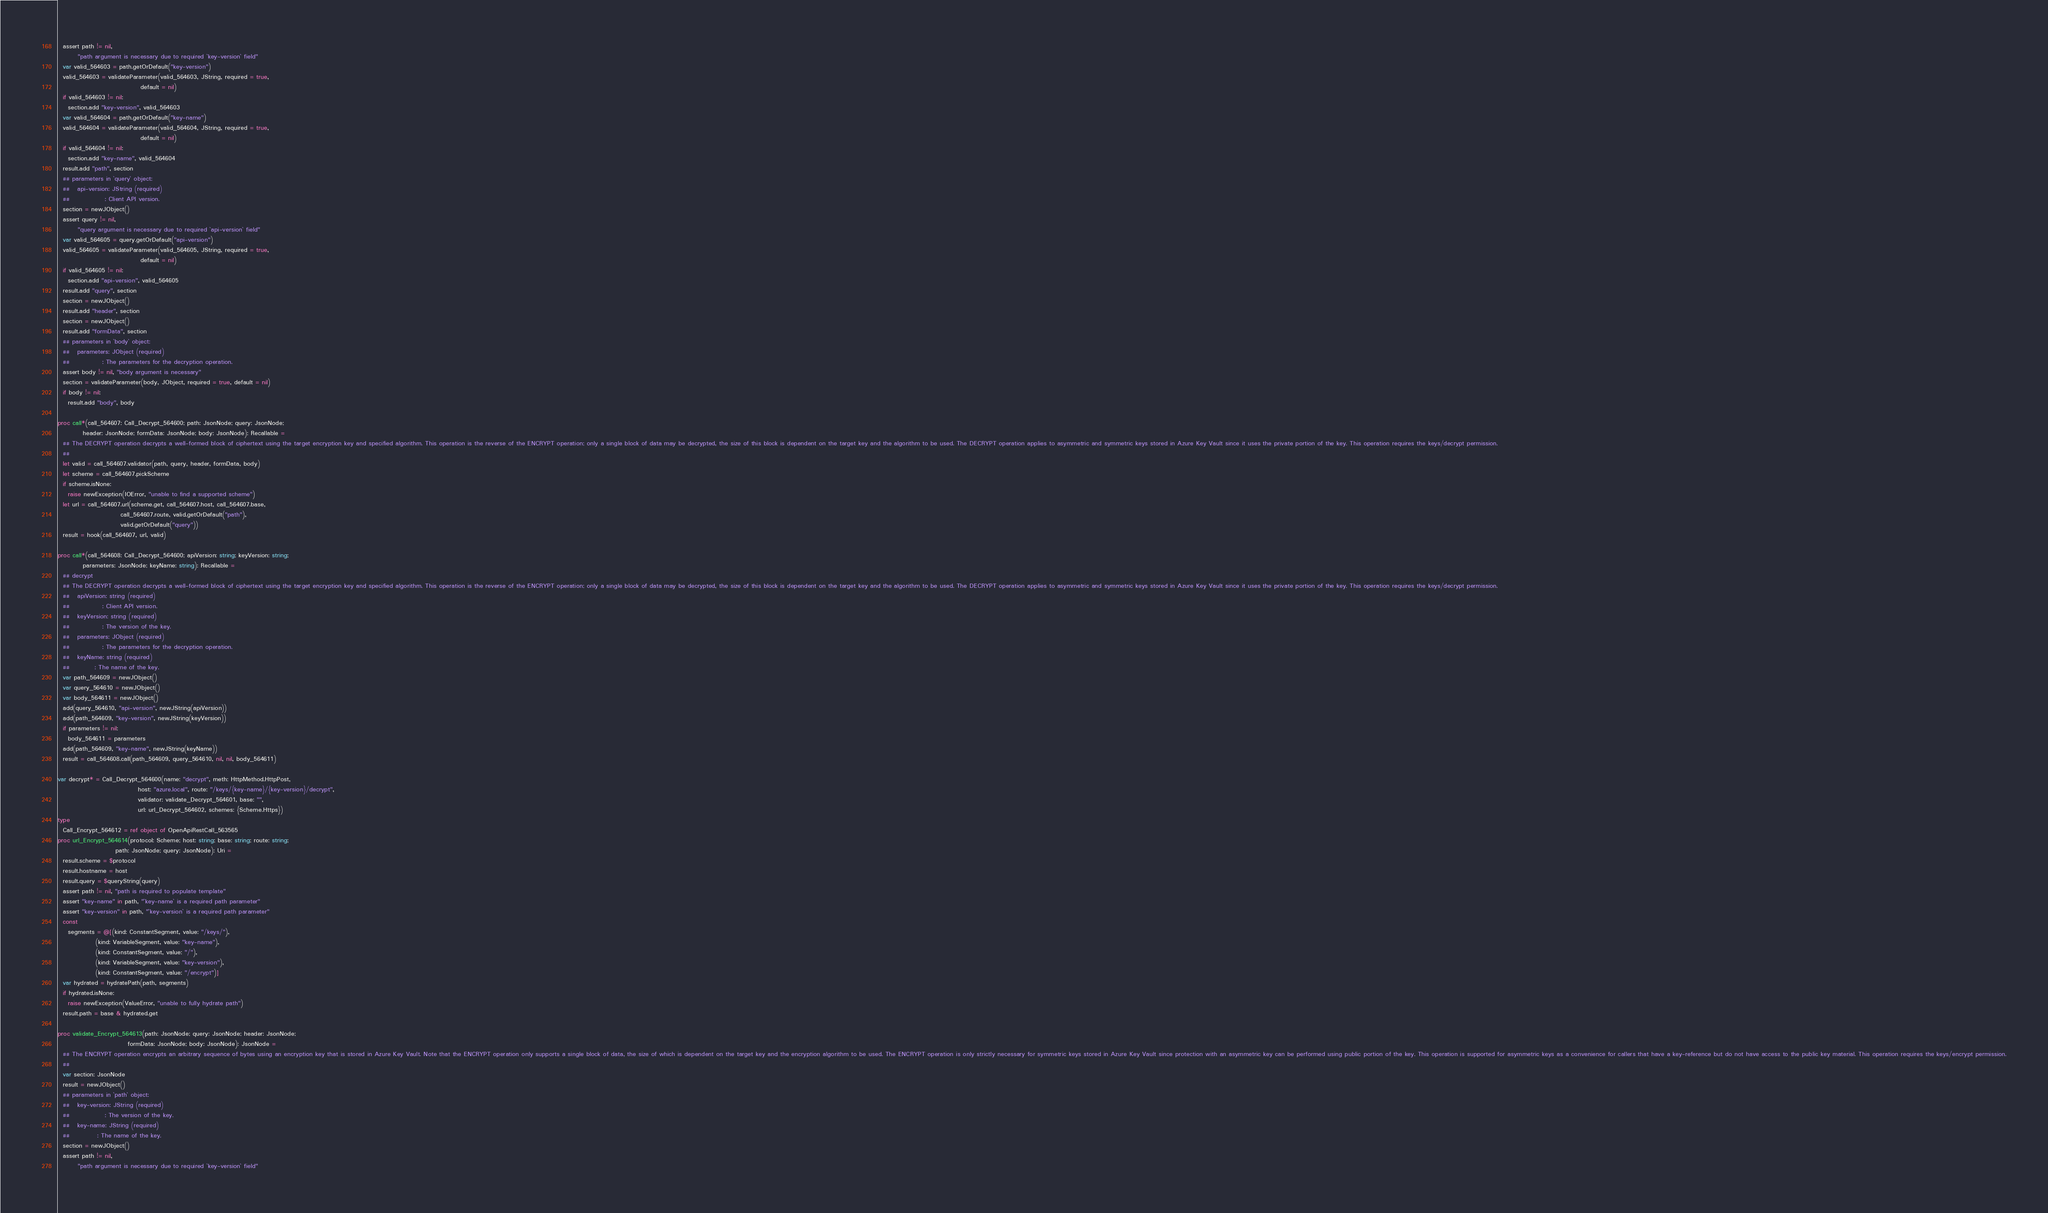Convert code to text. <code><loc_0><loc_0><loc_500><loc_500><_Nim_>  assert path != nil,
        "path argument is necessary due to required `key-version` field"
  var valid_564603 = path.getOrDefault("key-version")
  valid_564603 = validateParameter(valid_564603, JString, required = true,
                                 default = nil)
  if valid_564603 != nil:
    section.add "key-version", valid_564603
  var valid_564604 = path.getOrDefault("key-name")
  valid_564604 = validateParameter(valid_564604, JString, required = true,
                                 default = nil)
  if valid_564604 != nil:
    section.add "key-name", valid_564604
  result.add "path", section
  ## parameters in `query` object:
  ##   api-version: JString (required)
  ##              : Client API version.
  section = newJObject()
  assert query != nil,
        "query argument is necessary due to required `api-version` field"
  var valid_564605 = query.getOrDefault("api-version")
  valid_564605 = validateParameter(valid_564605, JString, required = true,
                                 default = nil)
  if valid_564605 != nil:
    section.add "api-version", valid_564605
  result.add "query", section
  section = newJObject()
  result.add "header", section
  section = newJObject()
  result.add "formData", section
  ## parameters in `body` object:
  ##   parameters: JObject (required)
  ##             : The parameters for the decryption operation.
  assert body != nil, "body argument is necessary"
  section = validateParameter(body, JObject, required = true, default = nil)
  if body != nil:
    result.add "body", body

proc call*(call_564607: Call_Decrypt_564600; path: JsonNode; query: JsonNode;
          header: JsonNode; formData: JsonNode; body: JsonNode): Recallable =
  ## The DECRYPT operation decrypts a well-formed block of ciphertext using the target encryption key and specified algorithm. This operation is the reverse of the ENCRYPT operation; only a single block of data may be decrypted, the size of this block is dependent on the target key and the algorithm to be used. The DECRYPT operation applies to asymmetric and symmetric keys stored in Azure Key Vault since it uses the private portion of the key. This operation requires the keys/decrypt permission.
  ## 
  let valid = call_564607.validator(path, query, header, formData, body)
  let scheme = call_564607.pickScheme
  if scheme.isNone:
    raise newException(IOError, "unable to find a supported scheme")
  let url = call_564607.url(scheme.get, call_564607.host, call_564607.base,
                         call_564607.route, valid.getOrDefault("path"),
                         valid.getOrDefault("query"))
  result = hook(call_564607, url, valid)

proc call*(call_564608: Call_Decrypt_564600; apiVersion: string; keyVersion: string;
          parameters: JsonNode; keyName: string): Recallable =
  ## decrypt
  ## The DECRYPT operation decrypts a well-formed block of ciphertext using the target encryption key and specified algorithm. This operation is the reverse of the ENCRYPT operation; only a single block of data may be decrypted, the size of this block is dependent on the target key and the algorithm to be used. The DECRYPT operation applies to asymmetric and symmetric keys stored in Azure Key Vault since it uses the private portion of the key. This operation requires the keys/decrypt permission.
  ##   apiVersion: string (required)
  ##             : Client API version.
  ##   keyVersion: string (required)
  ##             : The version of the key.
  ##   parameters: JObject (required)
  ##             : The parameters for the decryption operation.
  ##   keyName: string (required)
  ##          : The name of the key.
  var path_564609 = newJObject()
  var query_564610 = newJObject()
  var body_564611 = newJObject()
  add(query_564610, "api-version", newJString(apiVersion))
  add(path_564609, "key-version", newJString(keyVersion))
  if parameters != nil:
    body_564611 = parameters
  add(path_564609, "key-name", newJString(keyName))
  result = call_564608.call(path_564609, query_564610, nil, nil, body_564611)

var decrypt* = Call_Decrypt_564600(name: "decrypt", meth: HttpMethod.HttpPost,
                                host: "azure.local", route: "/keys/{key-name}/{key-version}/decrypt",
                                validator: validate_Decrypt_564601, base: "",
                                url: url_Decrypt_564602, schemes: {Scheme.Https})
type
  Call_Encrypt_564612 = ref object of OpenApiRestCall_563565
proc url_Encrypt_564614(protocol: Scheme; host: string; base: string; route: string;
                       path: JsonNode; query: JsonNode): Uri =
  result.scheme = $protocol
  result.hostname = host
  result.query = $queryString(query)
  assert path != nil, "path is required to populate template"
  assert "key-name" in path, "`key-name` is a required path parameter"
  assert "key-version" in path, "`key-version` is a required path parameter"
  const
    segments = @[(kind: ConstantSegment, value: "/keys/"),
               (kind: VariableSegment, value: "key-name"),
               (kind: ConstantSegment, value: "/"),
               (kind: VariableSegment, value: "key-version"),
               (kind: ConstantSegment, value: "/encrypt")]
  var hydrated = hydratePath(path, segments)
  if hydrated.isNone:
    raise newException(ValueError, "unable to fully hydrate path")
  result.path = base & hydrated.get

proc validate_Encrypt_564613(path: JsonNode; query: JsonNode; header: JsonNode;
                            formData: JsonNode; body: JsonNode): JsonNode =
  ## The ENCRYPT operation encrypts an arbitrary sequence of bytes using an encryption key that is stored in Azure Key Vault. Note that the ENCRYPT operation only supports a single block of data, the size of which is dependent on the target key and the encryption algorithm to be used. The ENCRYPT operation is only strictly necessary for symmetric keys stored in Azure Key Vault since protection with an asymmetric key can be performed using public portion of the key. This operation is supported for asymmetric keys as a convenience for callers that have a key-reference but do not have access to the public key material. This operation requires the keys/encrypt permission.
  ## 
  var section: JsonNode
  result = newJObject()
  ## parameters in `path` object:
  ##   key-version: JString (required)
  ##              : The version of the key.
  ##   key-name: JString (required)
  ##           : The name of the key.
  section = newJObject()
  assert path != nil,
        "path argument is necessary due to required `key-version` field"</code> 